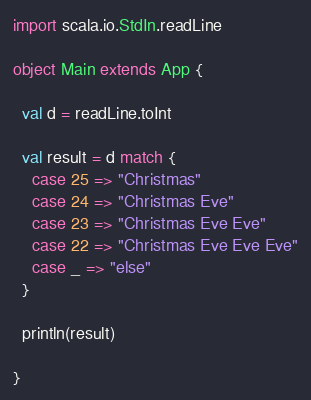Convert code to text. <code><loc_0><loc_0><loc_500><loc_500><_Scala_>import scala.io.StdIn.readLine

object Main extends App {

  val d = readLine.toInt

  val result = d match {
    case 25 => "Christmas"
    case 24 => "Christmas Eve"
    case 23 => "Christmas Eve Eve"
    case 22 => "Christmas Eve Eve Eve"
    case _ => "else"
  }

  println(result)

}</code> 